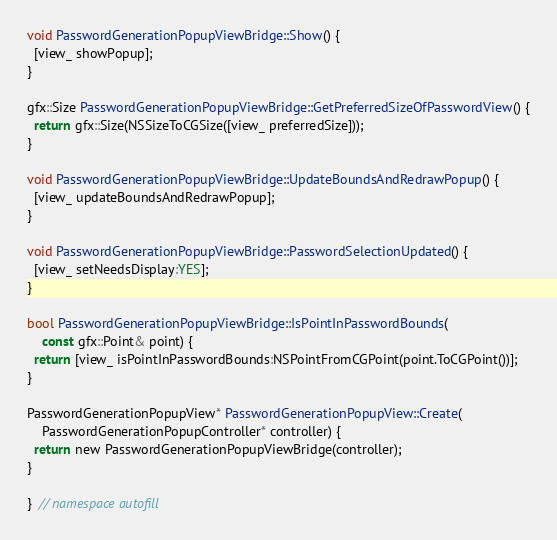<code> <loc_0><loc_0><loc_500><loc_500><_ObjectiveC_>void PasswordGenerationPopupViewBridge::Show() {
  [view_ showPopup];
}

gfx::Size PasswordGenerationPopupViewBridge::GetPreferredSizeOfPasswordView() {
  return gfx::Size(NSSizeToCGSize([view_ preferredSize]));
}

void PasswordGenerationPopupViewBridge::UpdateBoundsAndRedrawPopup() {
  [view_ updateBoundsAndRedrawPopup];
}

void PasswordGenerationPopupViewBridge::PasswordSelectionUpdated() {
  [view_ setNeedsDisplay:YES];
}

bool PasswordGenerationPopupViewBridge::IsPointInPasswordBounds(
    const gfx::Point& point) {
  return [view_ isPointInPasswordBounds:NSPointFromCGPoint(point.ToCGPoint())];
}

PasswordGenerationPopupView* PasswordGenerationPopupView::Create(
    PasswordGenerationPopupController* controller) {
  return new PasswordGenerationPopupViewBridge(controller);
}

}  // namespace autofill
</code> 